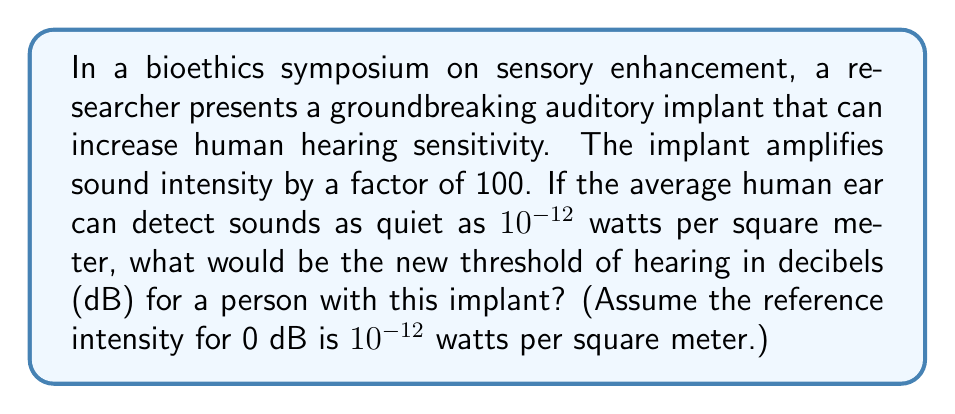Can you solve this math problem? To solve this problem, we need to use the logarithmic formula for sound intensity in decibels:

$$ \text{Intensity (dB)} = 10 \log_{10}\left(\frac{I}{I_0}\right) $$

Where:
- $I$ is the intensity of the sound
- $I_0$ is the reference intensity ($10^{-12}$ watts per square meter)

Given:
- The implant amplifies sound intensity by a factor of 100
- The new threshold of hearing will be 100 times more sensitive than the average human ear

Step 1: Calculate the new threshold of hearing intensity
$$ I_{\text{new}} = \frac{10^{-12}}{100} = 10^{-14} \text{ watts per square meter} $$

Step 2: Apply the formula for intensity in decibels
$$ \text{Intensity (dB)} = 10 \log_{10}\left(\frac{10^{-14}}{10^{-12}}\right) $$

Step 3: Simplify the fraction inside the logarithm
$$ \text{Intensity (dB)} = 10 \log_{10}\left(10^{-2}\right) $$

Step 4: Apply the logarithm rule: $\log_a(x^n) = n\log_a(x)$
$$ \text{Intensity (dB)} = 10 \cdot (-2) \log_{10}(10) $$

Step 5: Simplify, noting that $\log_{10}(10) = 1$
$$ \text{Intensity (dB)} = 10 \cdot (-2) \cdot 1 = -20 $$

Therefore, the new threshold of hearing for a person with this implant would be -20 dB.
Answer: -20 dB 